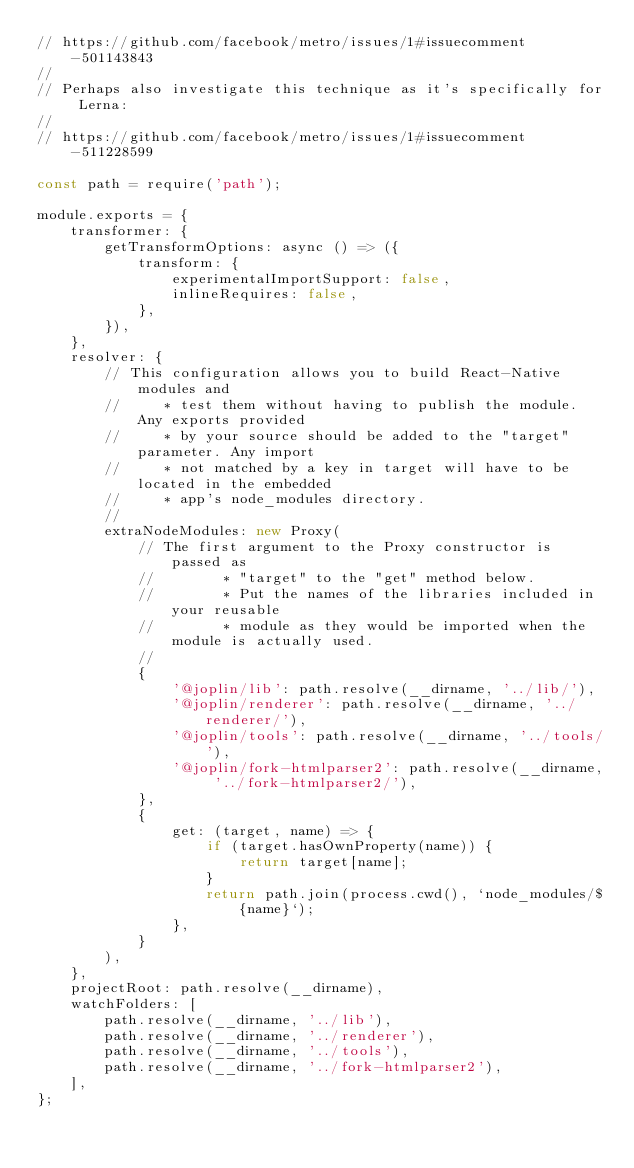<code> <loc_0><loc_0><loc_500><loc_500><_JavaScript_>// https://github.com/facebook/metro/issues/1#issuecomment-501143843
//
// Perhaps also investigate this technique as it's specifically for Lerna:
//
// https://github.com/facebook/metro/issues/1#issuecomment-511228599

const path = require('path');

module.exports = {
	transformer: {
		getTransformOptions: async () => ({
			transform: {
				experimentalImportSupport: false,
				inlineRequires: false,
			},
		}),
	},
	resolver: {
		// This configuration allows you to build React-Native modules and
		//     * test them without having to publish the module. Any exports provided
		//     * by your source should be added to the "target" parameter. Any import
		//     * not matched by a key in target will have to be located in the embedded
		//     * app's node_modules directory.
		//
		extraNodeModules: new Proxy(
			// The first argument to the Proxy constructor is passed as
			//        * "target" to the "get" method below.
			//        * Put the names of the libraries included in your reusable
			//        * module as they would be imported when the module is actually used.
			//
			{
				'@joplin/lib': path.resolve(__dirname, '../lib/'),
				'@joplin/renderer': path.resolve(__dirname, '../renderer/'),
				'@joplin/tools': path.resolve(__dirname, '../tools/'),
				'@joplin/fork-htmlparser2': path.resolve(__dirname, '../fork-htmlparser2/'),
			},
			{
				get: (target, name) => {
					if (target.hasOwnProperty(name)) {
						return target[name];
					}
					return path.join(process.cwd(), `node_modules/${name}`);
				},
			}
		),
	},
	projectRoot: path.resolve(__dirname),
	watchFolders: [
		path.resolve(__dirname, '../lib'),
		path.resolve(__dirname, '../renderer'),
		path.resolve(__dirname, '../tools'),
		path.resolve(__dirname, '../fork-htmlparser2'),
	],
};
</code> 